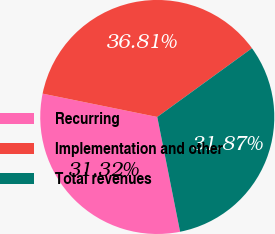Convert chart to OTSL. <chart><loc_0><loc_0><loc_500><loc_500><pie_chart><fcel>Recurring<fcel>Implementation and other<fcel>Total revenues<nl><fcel>31.32%<fcel>36.81%<fcel>31.87%<nl></chart> 